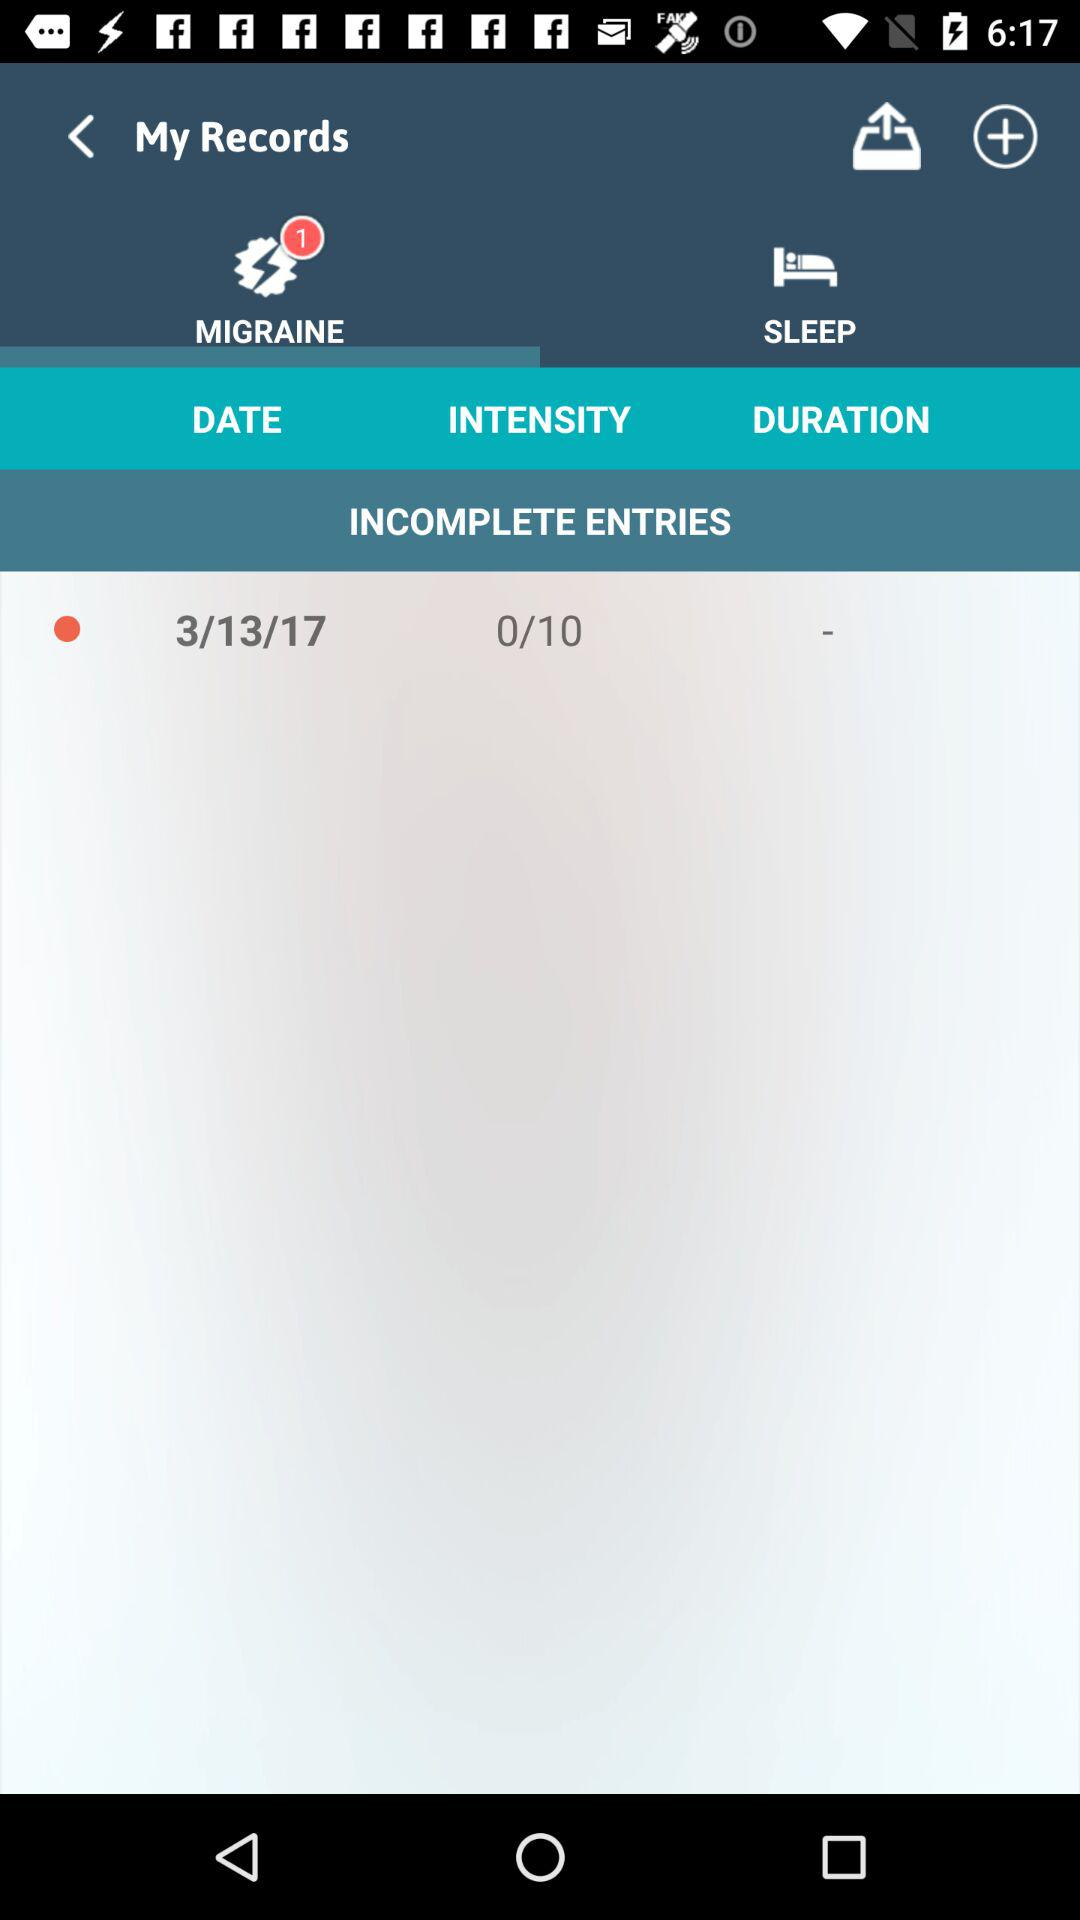Which tab is selected? The selected tab is "MIGRAINE". 